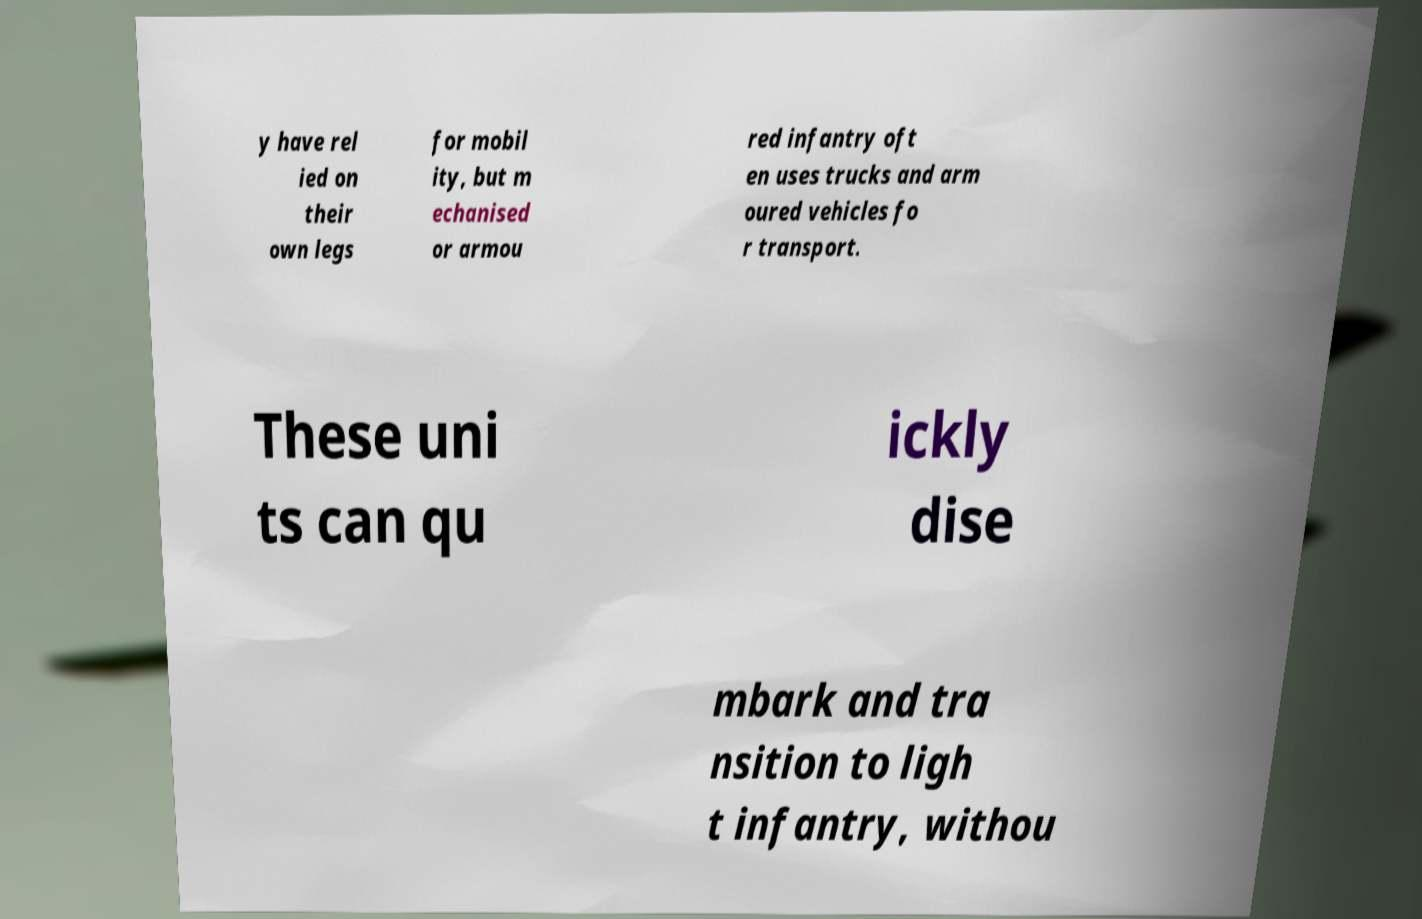Could you assist in decoding the text presented in this image and type it out clearly? y have rel ied on their own legs for mobil ity, but m echanised or armou red infantry oft en uses trucks and arm oured vehicles fo r transport. These uni ts can qu ickly dise mbark and tra nsition to ligh t infantry, withou 